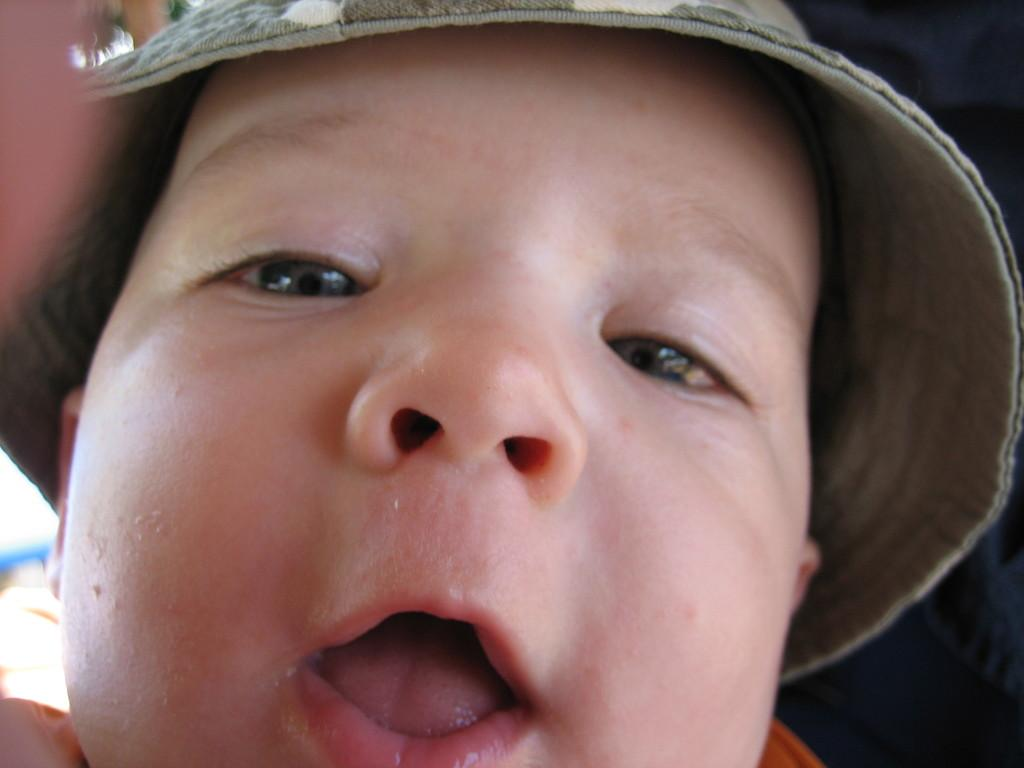What is the main subject of the picture? The main subject of the picture is a small baby. What is the baby wearing in the picture? The baby is wearing a hat in the picture. What action is the baby performing in the picture? The baby is opening its mouth in the picture. How many porters are carrying the baby in the picture? There are no porters present in the image; it features a small baby wearing a hat and opening its mouth. What type of metal is visible on the baby's feet in the picture? There is no metal, specifically zinc, visible on the baby's feet in the picture. 